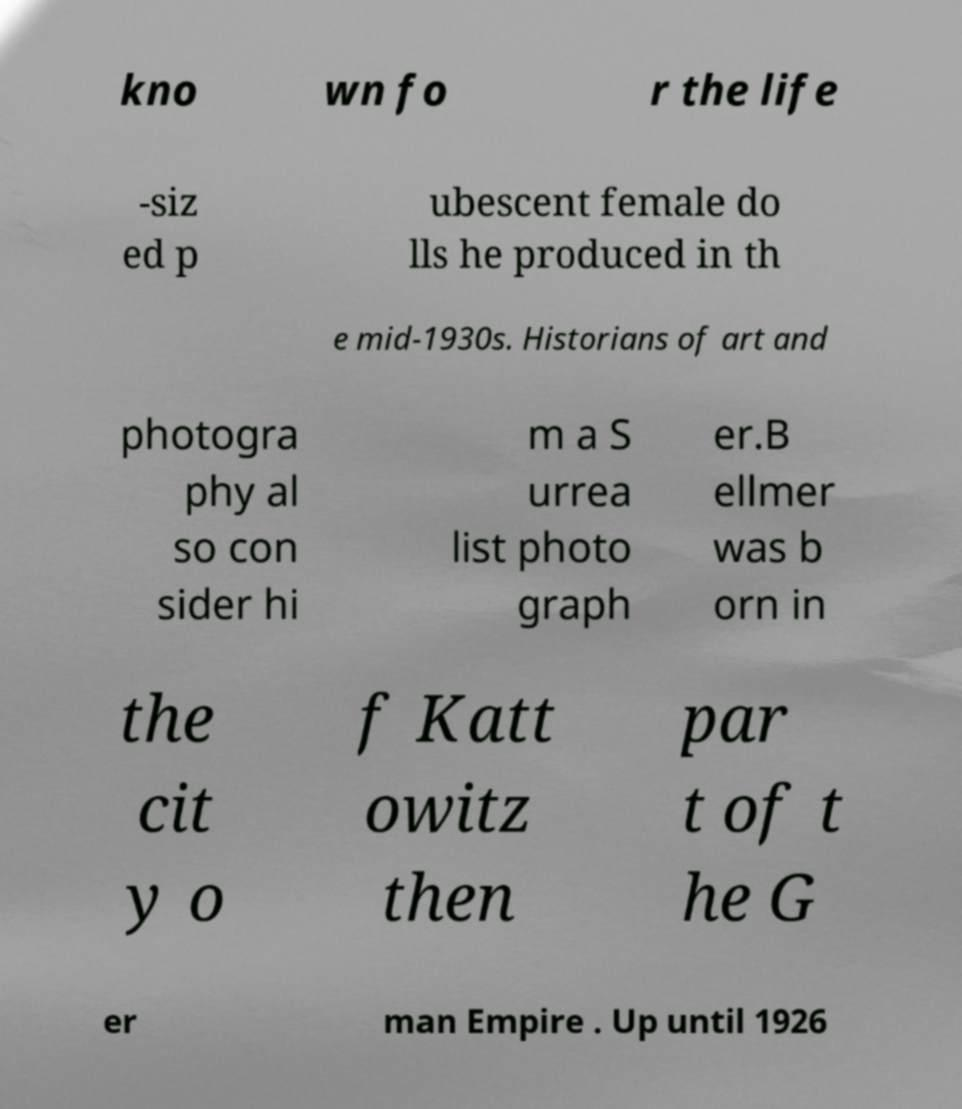Can you read and provide the text displayed in the image?This photo seems to have some interesting text. Can you extract and type it out for me? kno wn fo r the life -siz ed p ubescent female do lls he produced in th e mid-1930s. Historians of art and photogra phy al so con sider hi m a S urrea list photo graph er.B ellmer was b orn in the cit y o f Katt owitz then par t of t he G er man Empire . Up until 1926 